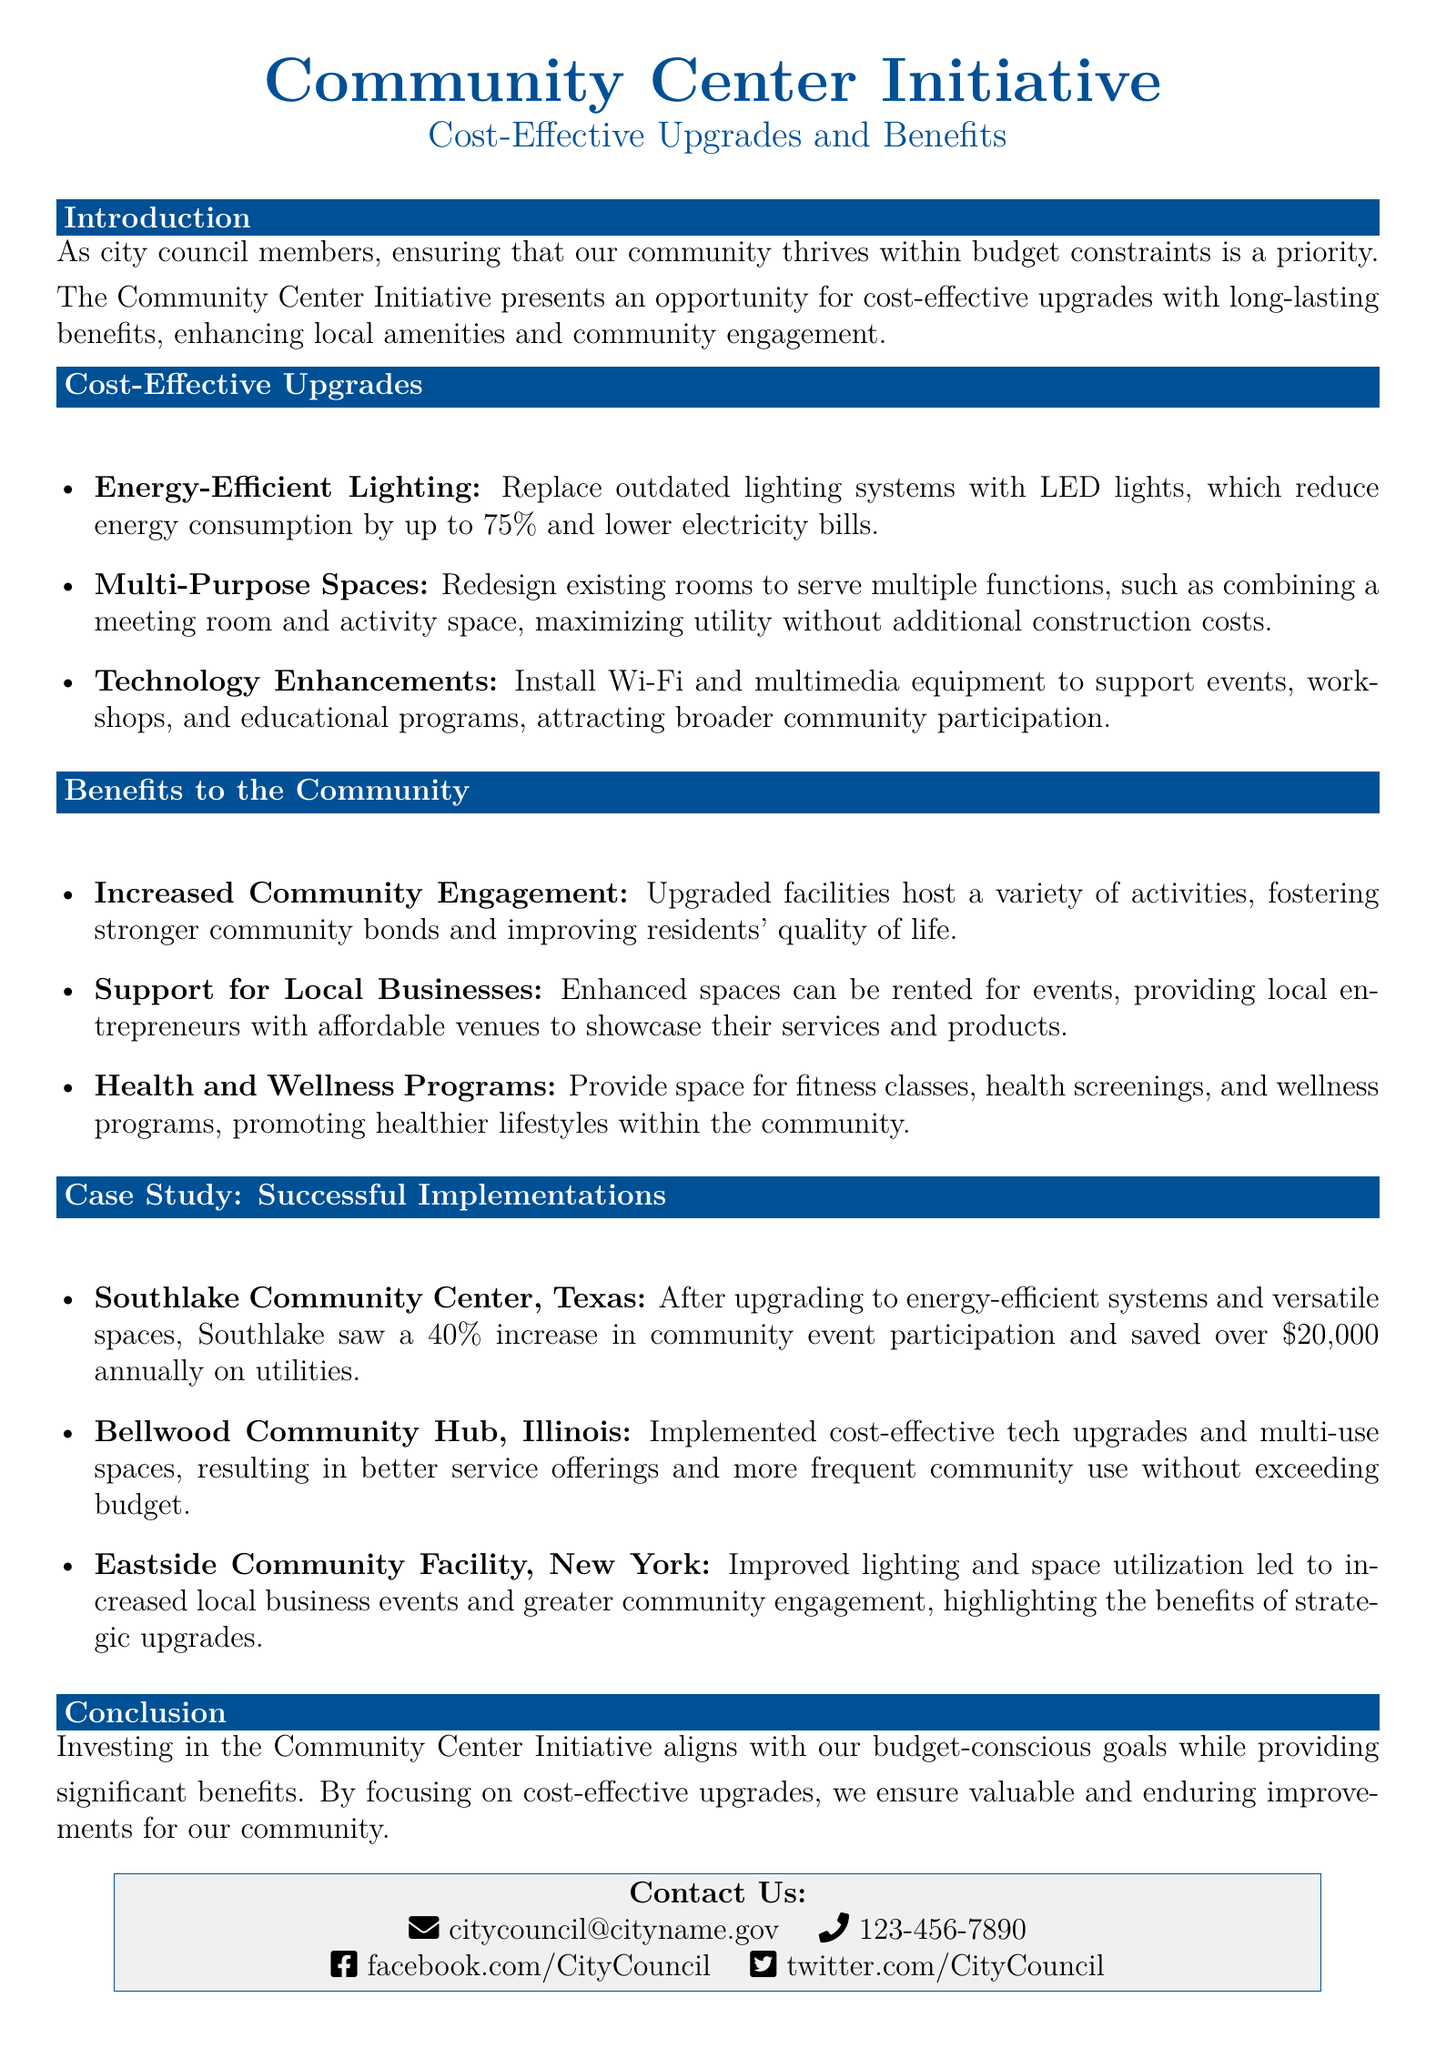What is the primary goal of the Community Center Initiative? The primary goal is to ensure that our community thrives within budget constraints.
Answer: budget constraints What type of lighting is suggested for upgrades? The document suggests replacing outdated lighting systems with energy-efficient lighting.
Answer: LED lights How much can energy-efficient lighting reduce energy consumption? The document states that energy-efficient lighting can reduce energy consumption by a specific percentage.
Answer: 75% Which community center case study resulted in a 40% increase in event participation? The Southlake Community Center in Texas reported this increase after upgrades.
Answer: Southlake Community Center, Texas What are multi-purpose spaces designed to do? Multi-purpose spaces are designed to serve multiple functions, maximizing utility without additional costs.
Answer: serve multiple functions What is one benefit to local businesses mentioned in the document? Enhanced spaces providing affordable venues for local entrepreneurs to showcase services is mentioned.
Answer: affordable venues How can the Community Center Initiative promote health? The initiative promotes health through the provision of space for certain programs.
Answer: health and wellness programs What is the contact email provided in the document? The email contact for the city council is given.
Answer: citycouncil@cityname.gov 